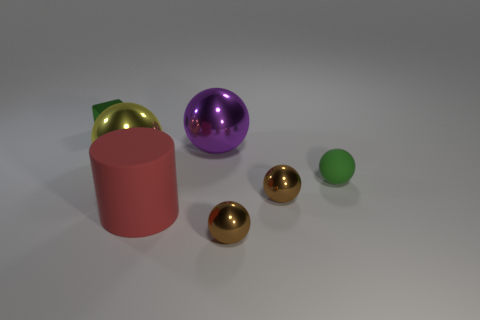Subtract all large purple spheres. How many spheres are left? 4 Subtract all green balls. How many balls are left? 4 Subtract 1 spheres. How many spheres are left? 4 Subtract all red balls. Subtract all blue cylinders. How many balls are left? 5 Add 3 tiny brown matte objects. How many objects exist? 10 Subtract all cubes. How many objects are left? 6 Subtract all yellow shiny objects. Subtract all brown metal objects. How many objects are left? 4 Add 2 brown objects. How many brown objects are left? 4 Add 6 purple cylinders. How many purple cylinders exist? 6 Subtract 1 red cylinders. How many objects are left? 6 